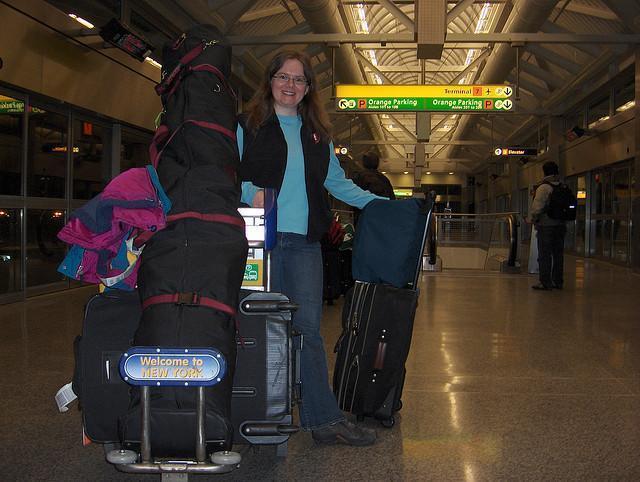What color are the straps wrapping up the black duffel on the luggage rack?
Indicate the correct response by choosing from the four available options to answer the question.
Options: Beige, purple, orange, blue. Purple. What is the woman likely to use to get back home?
Pick the correct solution from the four options below to address the question.
Options: Car, airplane, taxi, covered wagon. Airplane. 